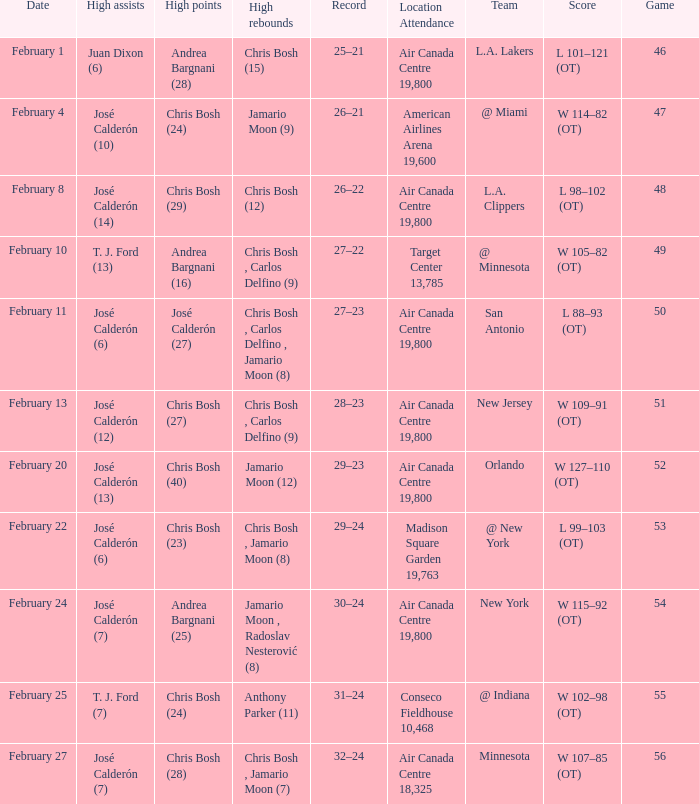What is the date of Game 50? February 11. 